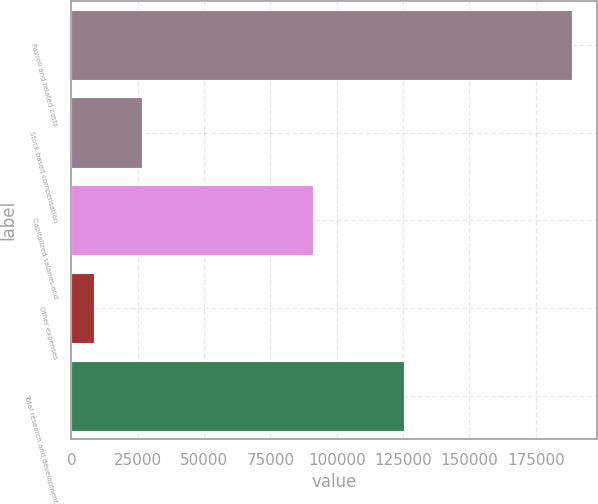Convert chart to OTSL. <chart><loc_0><loc_0><loc_500><loc_500><bar_chart><fcel>Payroll and related costs<fcel>Stock-based compensation<fcel>Capitalized salaries and<fcel>Other expenses<fcel>Total research and development<nl><fcel>188509<fcel>26529.7<fcel>91106<fcel>8532<fcel>125286<nl></chart> 